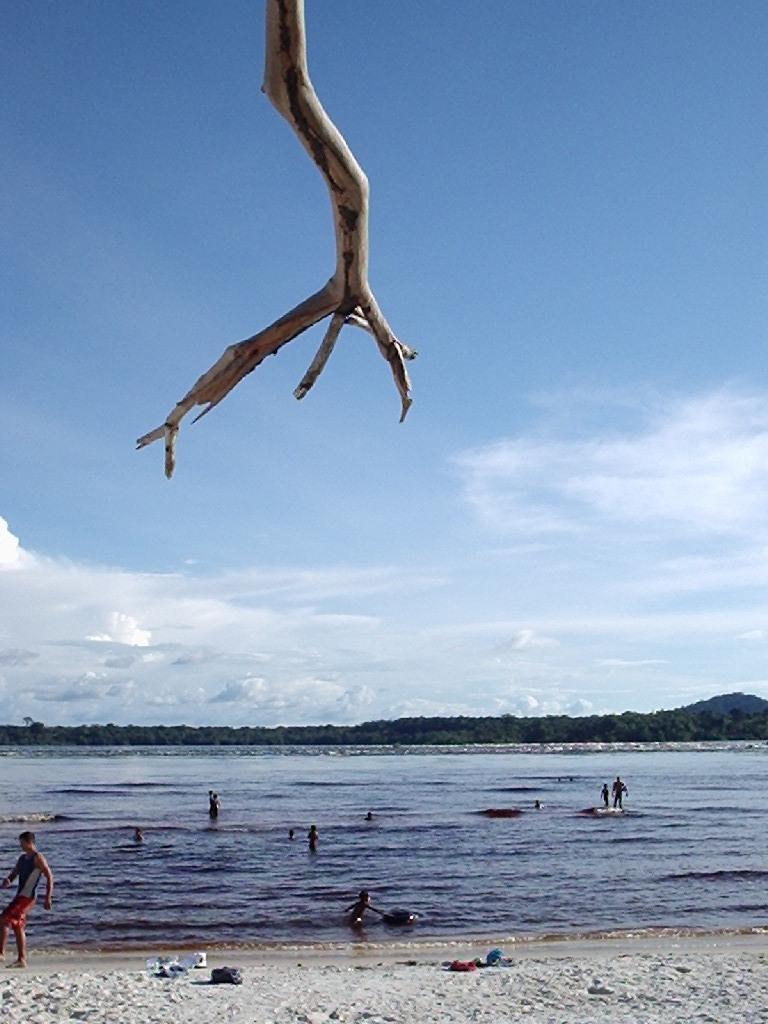Could you give a brief overview of what you see in this image? In this image on the left there is a man, he wears a t shirt, trouser. In the middle there are many people, water, waves, hills, sand, clothes. At the top there are clouds, sky, stick. 